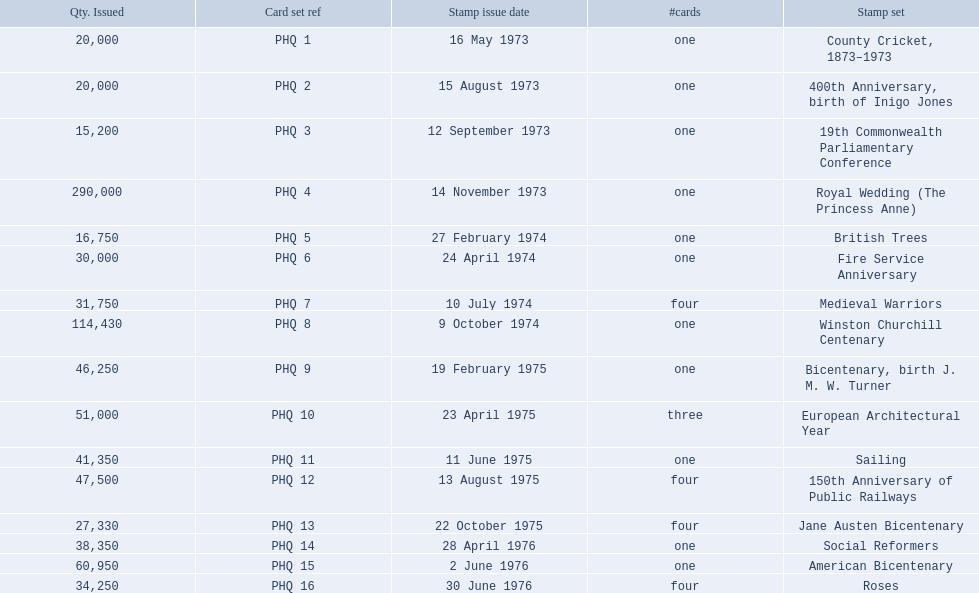What are all the stamp sets? County Cricket, 1873–1973, 400th Anniversary, birth of Inigo Jones, 19th Commonwealth Parliamentary Conference, Royal Wedding (The Princess Anne), British Trees, Fire Service Anniversary, Medieval Warriors, Winston Churchill Centenary, Bicentenary, birth J. M. W. Turner, European Architectural Year, Sailing, 150th Anniversary of Public Railways, Jane Austen Bicentenary, Social Reformers, American Bicentenary, Roses. For these sets, what were the quantities issued? 20,000, 20,000, 15,200, 290,000, 16,750, 30,000, 31,750, 114,430, 46,250, 51,000, 41,350, 47,500, 27,330, 38,350, 60,950, 34,250. Can you give me this table in json format? {'header': ['Qty. Issued', 'Card set ref', 'Stamp issue date', '#cards', 'Stamp set'], 'rows': [['20,000', 'PHQ 1', '16 May 1973', 'one', 'County Cricket, 1873–1973'], ['20,000', 'PHQ 2', '15 August 1973', 'one', '400th Anniversary, birth of Inigo Jones'], ['15,200', 'PHQ 3', '12 September 1973', 'one', '19th Commonwealth Parliamentary Conference'], ['290,000', 'PHQ 4', '14 November 1973', 'one', 'Royal Wedding (The Princess Anne)'], ['16,750', 'PHQ 5', '27 February 1974', 'one', 'British Trees'], ['30,000', 'PHQ 6', '24 April 1974', 'one', 'Fire Service Anniversary'], ['31,750', 'PHQ 7', '10 July 1974', 'four', 'Medieval Warriors'], ['114,430', 'PHQ 8', '9 October 1974', 'one', 'Winston Churchill Centenary'], ['46,250', 'PHQ 9', '19 February 1975', 'one', 'Bicentenary, birth J. M. W. Turner'], ['51,000', 'PHQ 10', '23 April 1975', 'three', 'European Architectural Year'], ['41,350', 'PHQ 11', '11 June 1975', 'one', 'Sailing'], ['47,500', 'PHQ 12', '13 August 1975', 'four', '150th Anniversary of Public Railways'], ['27,330', 'PHQ 13', '22 October 1975', 'four', 'Jane Austen Bicentenary'], ['38,350', 'PHQ 14', '28 April 1976', 'one', 'Social Reformers'], ['60,950', 'PHQ 15', '2 June 1976', 'one', 'American Bicentenary'], ['34,250', 'PHQ 16', '30 June 1976', 'four', 'Roses']]} Of these, which quantity is above 200,000? 290,000. What is the stamp set corresponding to this quantity? Royal Wedding (The Princess Anne). 